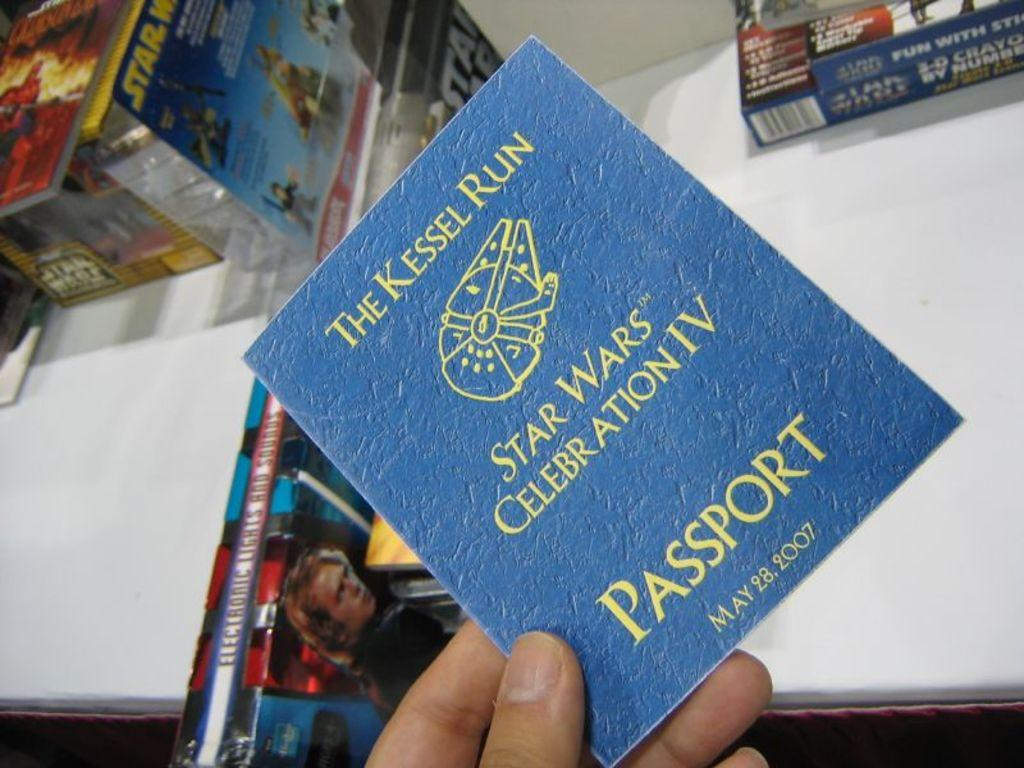Provide a one-sentence caption for the provided image. A blue Star Wars passport for Star Wars Celebration IV in 2007. 